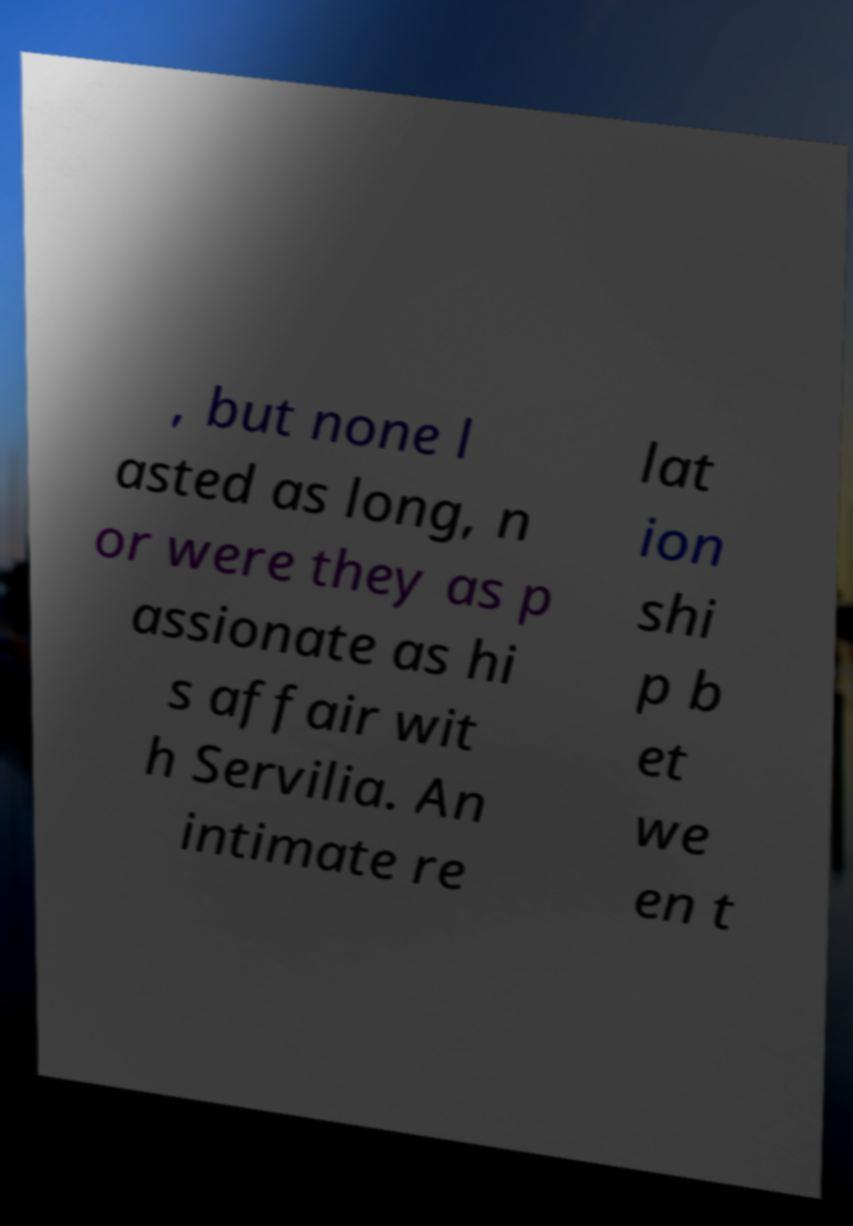I need the written content from this picture converted into text. Can you do that? , but none l asted as long, n or were they as p assionate as hi s affair wit h Servilia. An intimate re lat ion shi p b et we en t 